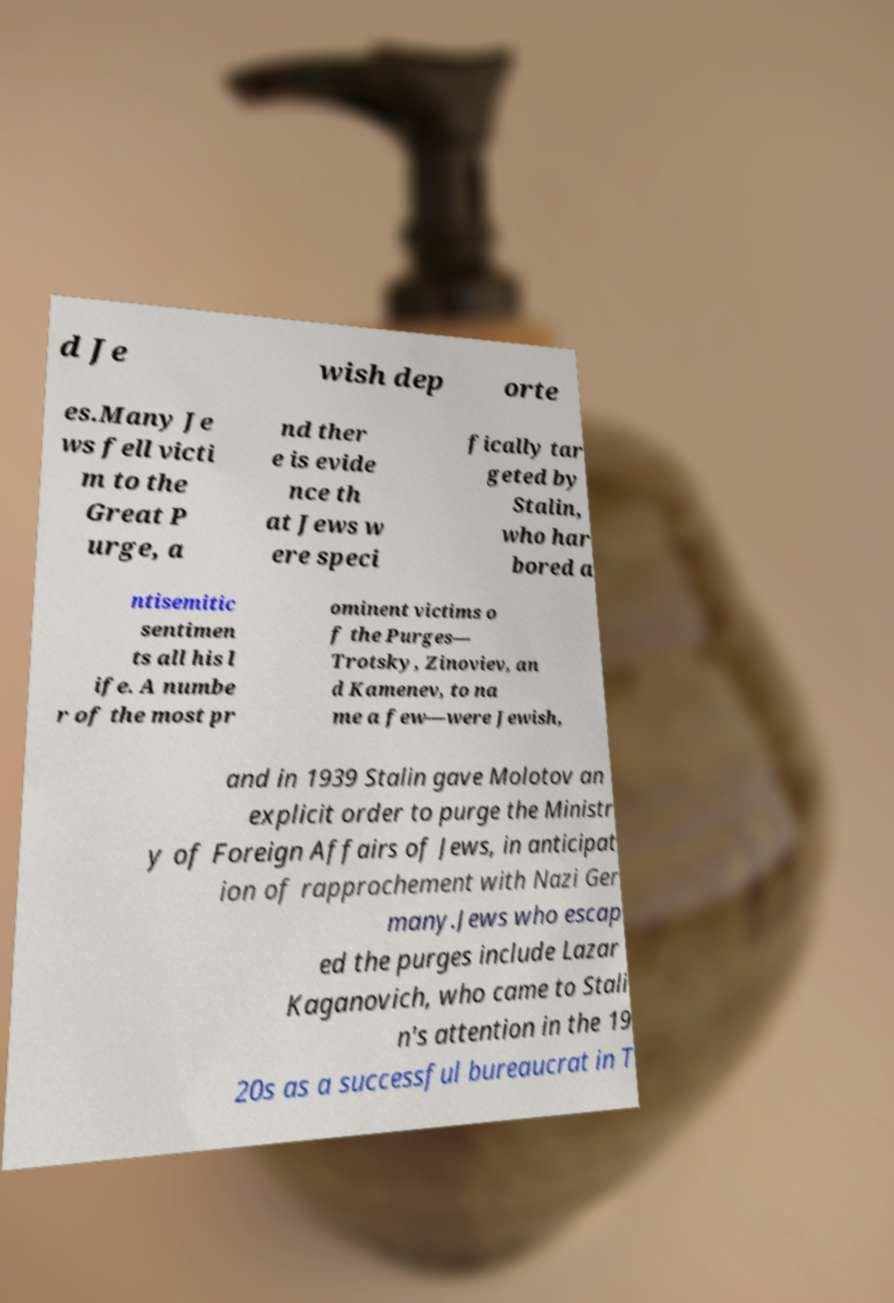For documentation purposes, I need the text within this image transcribed. Could you provide that? d Je wish dep orte es.Many Je ws fell victi m to the Great P urge, a nd ther e is evide nce th at Jews w ere speci fically tar geted by Stalin, who har bored a ntisemitic sentimen ts all his l ife. A numbe r of the most pr ominent victims o f the Purges— Trotsky, Zinoviev, an d Kamenev, to na me a few—were Jewish, and in 1939 Stalin gave Molotov an explicit order to purge the Ministr y of Foreign Affairs of Jews, in anticipat ion of rapprochement with Nazi Ger many.Jews who escap ed the purges include Lazar Kaganovich, who came to Stali n's attention in the 19 20s as a successful bureaucrat in T 